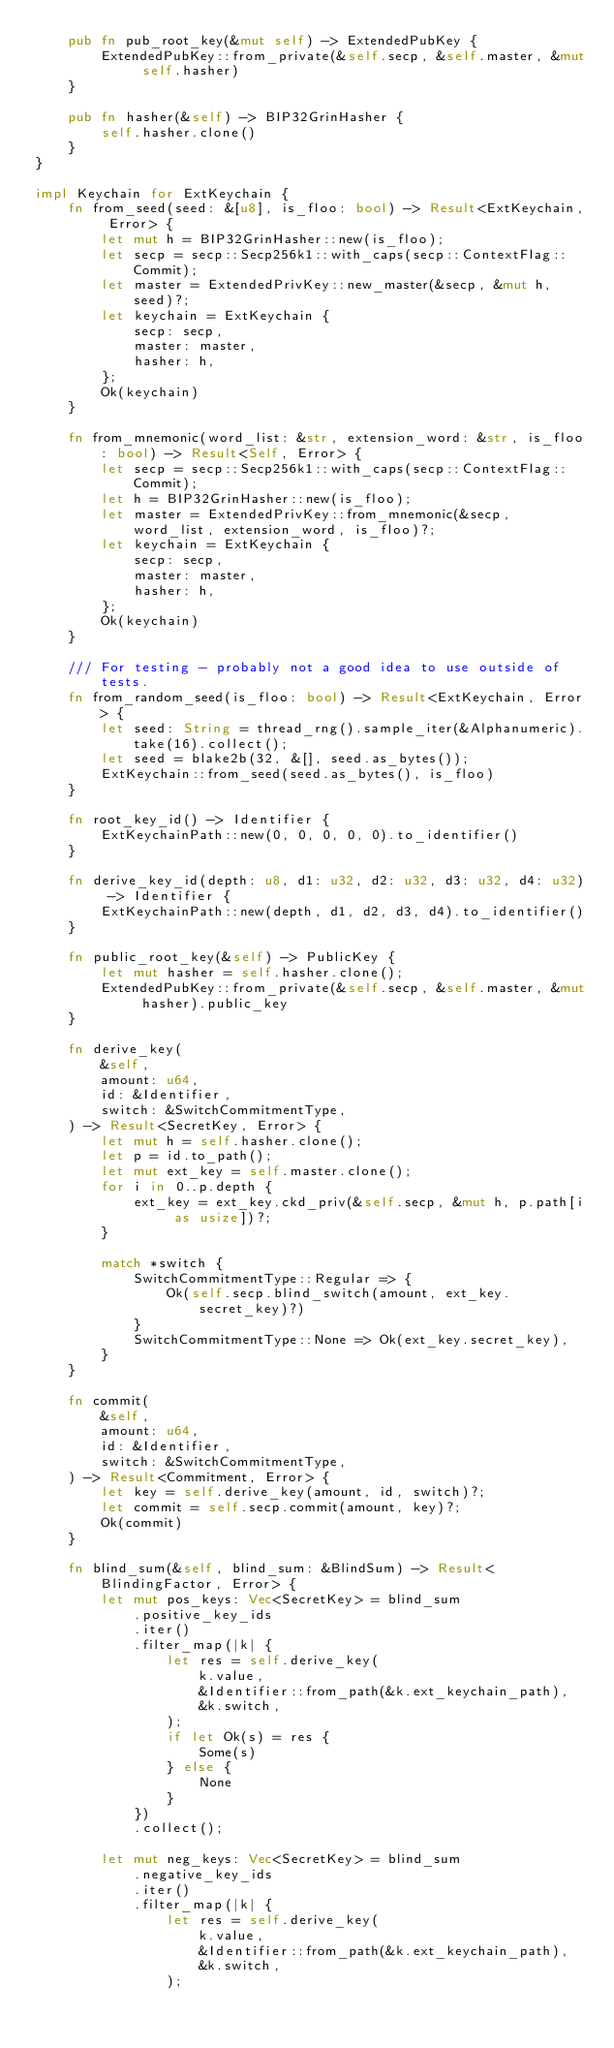<code> <loc_0><loc_0><loc_500><loc_500><_Rust_>	pub fn pub_root_key(&mut self) -> ExtendedPubKey {
		ExtendedPubKey::from_private(&self.secp, &self.master, &mut self.hasher)
	}

	pub fn hasher(&self) -> BIP32GrinHasher {
		self.hasher.clone()
	}
}

impl Keychain for ExtKeychain {
	fn from_seed(seed: &[u8], is_floo: bool) -> Result<ExtKeychain, Error> {
		let mut h = BIP32GrinHasher::new(is_floo);
		let secp = secp::Secp256k1::with_caps(secp::ContextFlag::Commit);
		let master = ExtendedPrivKey::new_master(&secp, &mut h, seed)?;
		let keychain = ExtKeychain {
			secp: secp,
			master: master,
			hasher: h,
		};
		Ok(keychain)
	}

	fn from_mnemonic(word_list: &str, extension_word: &str, is_floo: bool) -> Result<Self, Error> {
		let secp = secp::Secp256k1::with_caps(secp::ContextFlag::Commit);
		let h = BIP32GrinHasher::new(is_floo);
		let master = ExtendedPrivKey::from_mnemonic(&secp, word_list, extension_word, is_floo)?;
		let keychain = ExtKeychain {
			secp: secp,
			master: master,
			hasher: h,
		};
		Ok(keychain)
	}

	/// For testing - probably not a good idea to use outside of tests.
	fn from_random_seed(is_floo: bool) -> Result<ExtKeychain, Error> {
		let seed: String = thread_rng().sample_iter(&Alphanumeric).take(16).collect();
		let seed = blake2b(32, &[], seed.as_bytes());
		ExtKeychain::from_seed(seed.as_bytes(), is_floo)
	}

	fn root_key_id() -> Identifier {
		ExtKeychainPath::new(0, 0, 0, 0, 0).to_identifier()
	}

	fn derive_key_id(depth: u8, d1: u32, d2: u32, d3: u32, d4: u32) -> Identifier {
		ExtKeychainPath::new(depth, d1, d2, d3, d4).to_identifier()
	}

	fn public_root_key(&self) -> PublicKey {
		let mut hasher = self.hasher.clone();
		ExtendedPubKey::from_private(&self.secp, &self.master, &mut hasher).public_key
	}

	fn derive_key(
		&self,
		amount: u64,
		id: &Identifier,
		switch: &SwitchCommitmentType,
	) -> Result<SecretKey, Error> {
		let mut h = self.hasher.clone();
		let p = id.to_path();
		let mut ext_key = self.master.clone();
		for i in 0..p.depth {
			ext_key = ext_key.ckd_priv(&self.secp, &mut h, p.path[i as usize])?;
		}

		match *switch {
			SwitchCommitmentType::Regular => {
				Ok(self.secp.blind_switch(amount, ext_key.secret_key)?)
			}
			SwitchCommitmentType::None => Ok(ext_key.secret_key),
		}
	}

	fn commit(
		&self,
		amount: u64,
		id: &Identifier,
		switch: &SwitchCommitmentType,
	) -> Result<Commitment, Error> {
		let key = self.derive_key(amount, id, switch)?;
		let commit = self.secp.commit(amount, key)?;
		Ok(commit)
	}

	fn blind_sum(&self, blind_sum: &BlindSum) -> Result<BlindingFactor, Error> {
		let mut pos_keys: Vec<SecretKey> = blind_sum
			.positive_key_ids
			.iter()
			.filter_map(|k| {
				let res = self.derive_key(
					k.value,
					&Identifier::from_path(&k.ext_keychain_path),
					&k.switch,
				);
				if let Ok(s) = res {
					Some(s)
				} else {
					None
				}
			})
			.collect();

		let mut neg_keys: Vec<SecretKey> = blind_sum
			.negative_key_ids
			.iter()
			.filter_map(|k| {
				let res = self.derive_key(
					k.value,
					&Identifier::from_path(&k.ext_keychain_path),
					&k.switch,
				);</code> 